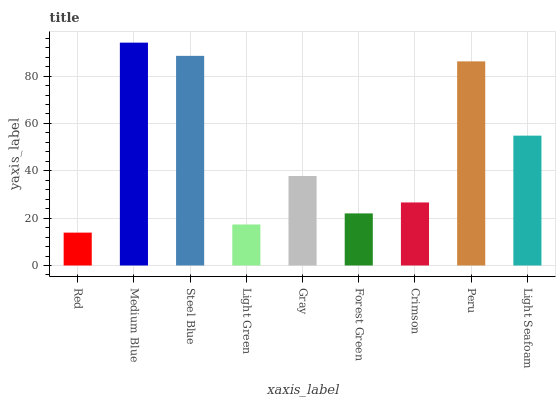Is Steel Blue the minimum?
Answer yes or no. No. Is Steel Blue the maximum?
Answer yes or no. No. Is Medium Blue greater than Steel Blue?
Answer yes or no. Yes. Is Steel Blue less than Medium Blue?
Answer yes or no. Yes. Is Steel Blue greater than Medium Blue?
Answer yes or no. No. Is Medium Blue less than Steel Blue?
Answer yes or no. No. Is Gray the high median?
Answer yes or no. Yes. Is Gray the low median?
Answer yes or no. Yes. Is Light Green the high median?
Answer yes or no. No. Is Red the low median?
Answer yes or no. No. 